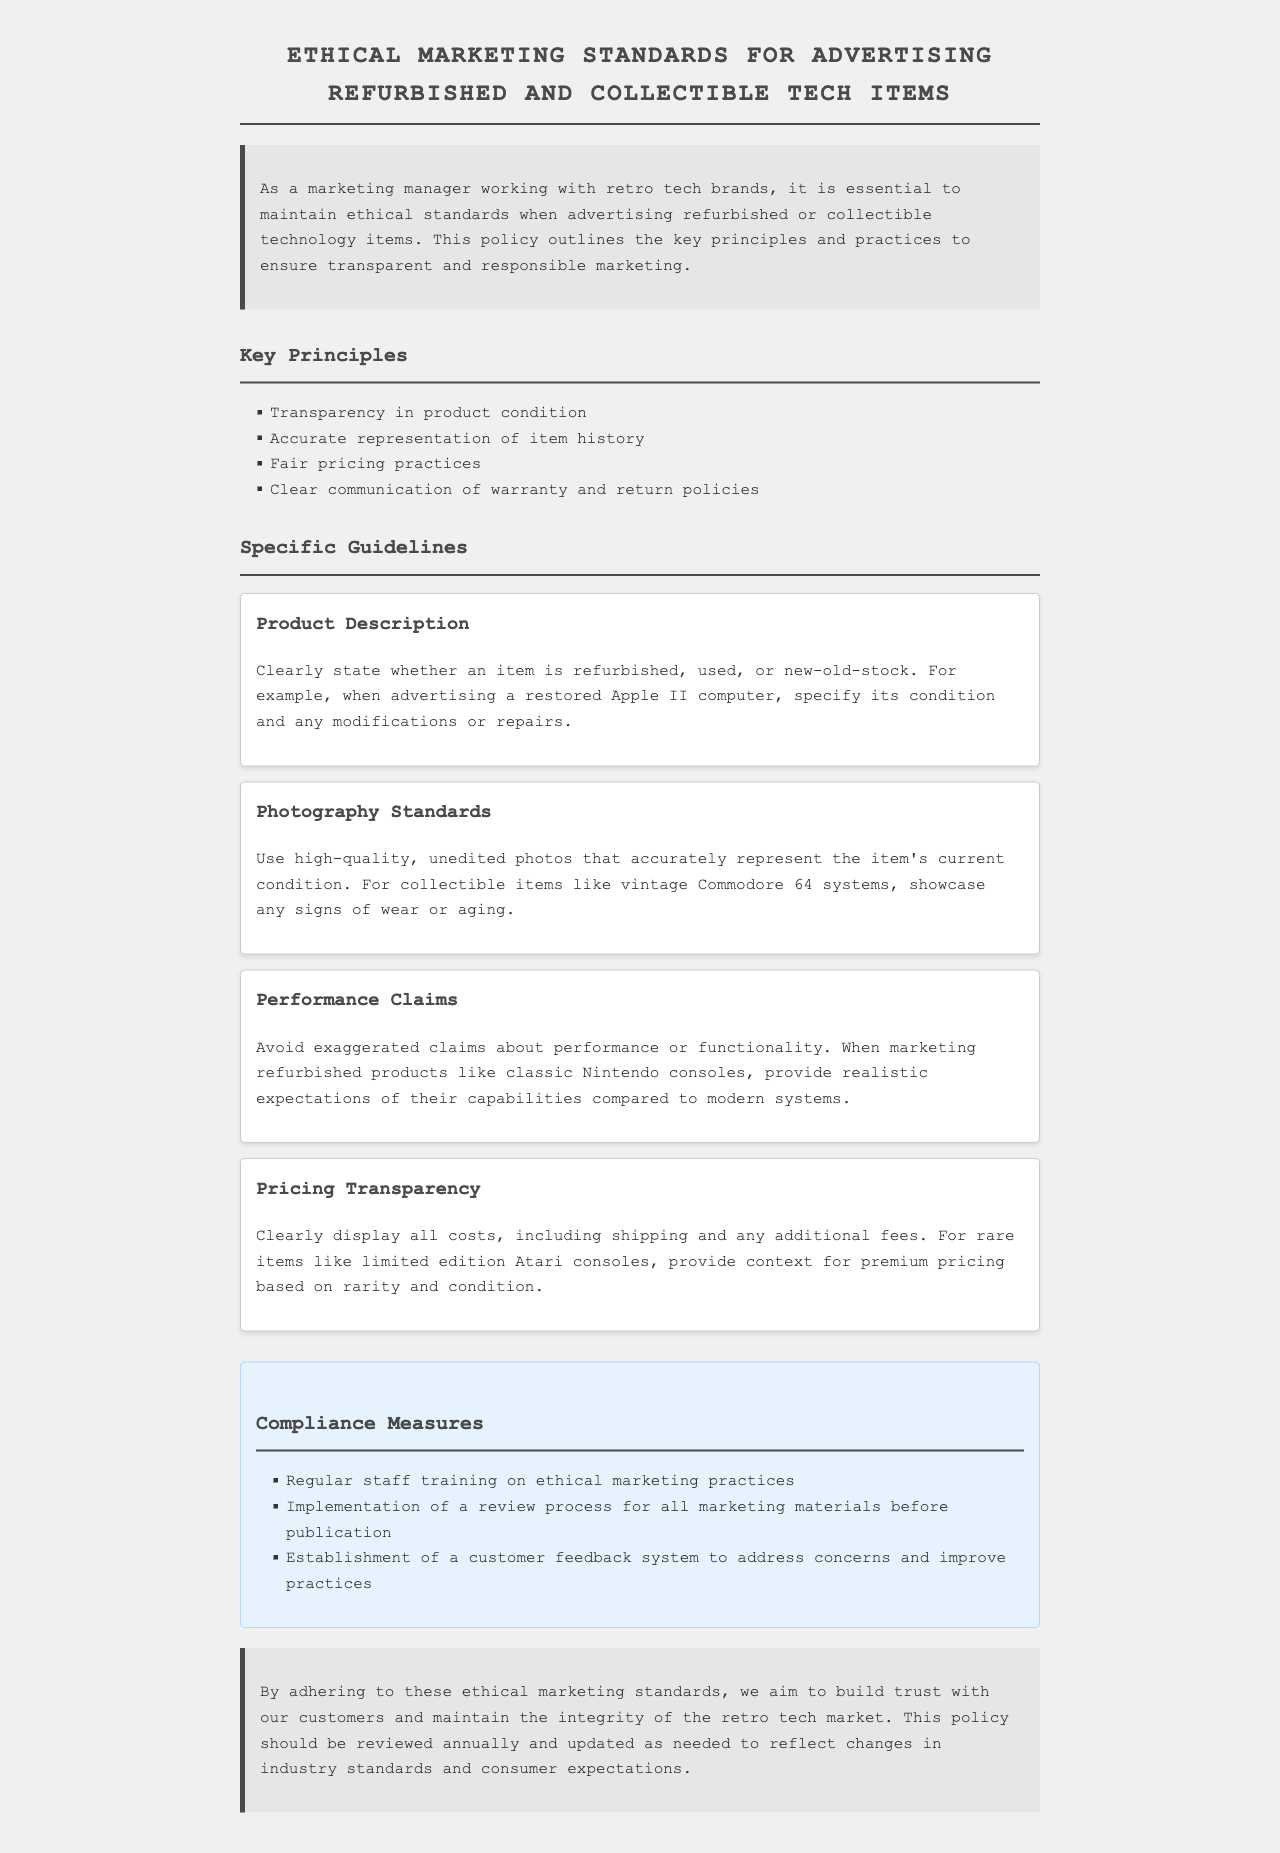What are the key principles of ethical marketing? The key principles are listed in the "Key Principles" section of the document.
Answer: Transparency in product condition, Accurate representation of item history, Fair pricing practices, Clear communication of warranty and return policies What is required in product descriptions? The guideline "Product Description" outlines requirements for clarity in stating the item's condition and modifications.
Answer: Clearly state whether an item is refurbished, used, or new-old-stock What type of photographs should be used for advertising? The "Photography Standards" guideline details requirements for image quality and honesty regarding item condition.
Answer: Use high-quality, unedited photos What should be avoided in performance claims? The "Performance Claims" guideline suggests avoiding unrealistic or exaggerated claims.
Answer: Exaggerated claims about performance or functionality How many compliance measures are listed in the document? The "Compliance Measures" section presents a list which needs to be counted.
Answer: Three What is the purpose of the compliance measures? The purpose is reflected in their description and intent in the document.
Answer: To address concerns and improve practices How often should the policy be reviewed? The conclusion states how regularly the policy should undergo review.
Answer: Annually 